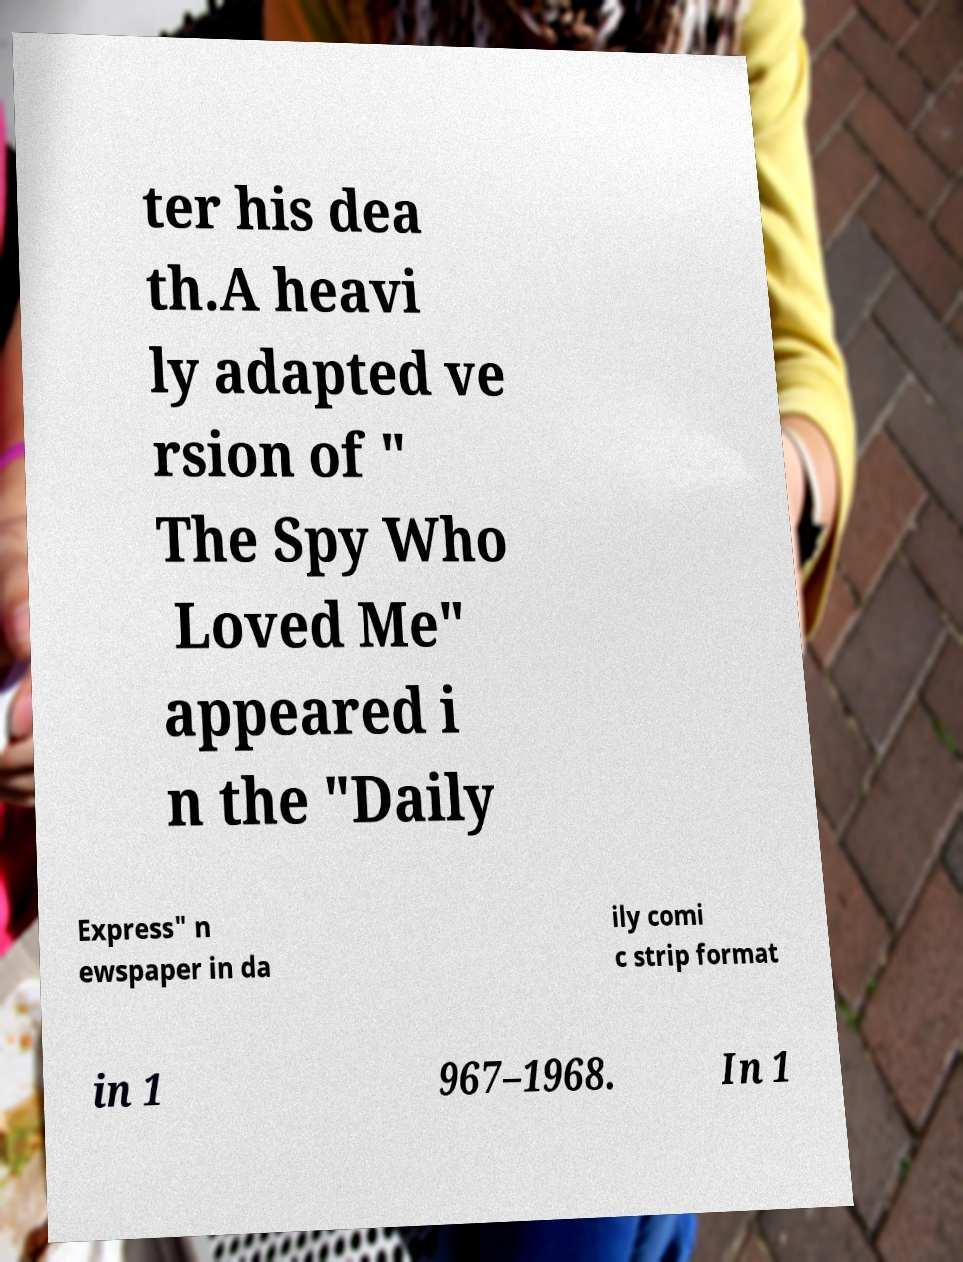Please identify and transcribe the text found in this image. ter his dea th.A heavi ly adapted ve rsion of " The Spy Who Loved Me" appeared i n the "Daily Express" n ewspaper in da ily comi c strip format in 1 967–1968. In 1 